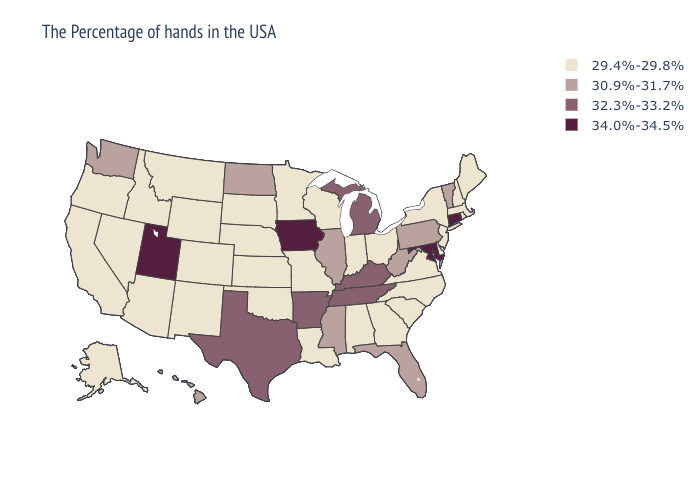Name the states that have a value in the range 32.3%-33.2%?
Concise answer only. Michigan, Kentucky, Tennessee, Arkansas, Texas. What is the lowest value in the MidWest?
Short answer required. 29.4%-29.8%. Does Missouri have a lower value than Alabama?
Concise answer only. No. What is the lowest value in the USA?
Write a very short answer. 29.4%-29.8%. Which states have the lowest value in the USA?
Keep it brief. Maine, Massachusetts, Rhode Island, New Hampshire, New York, New Jersey, Delaware, Virginia, North Carolina, South Carolina, Ohio, Georgia, Indiana, Alabama, Wisconsin, Louisiana, Missouri, Minnesota, Kansas, Nebraska, Oklahoma, South Dakota, Wyoming, Colorado, New Mexico, Montana, Arizona, Idaho, Nevada, California, Oregon, Alaska. What is the value of Pennsylvania?
Be succinct. 30.9%-31.7%. Does Ohio have the highest value in the MidWest?
Quick response, please. No. What is the value of New York?
Be succinct. 29.4%-29.8%. What is the highest value in states that border Washington?
Answer briefly. 29.4%-29.8%. What is the lowest value in the USA?
Quick response, please. 29.4%-29.8%. What is the lowest value in the USA?
Short answer required. 29.4%-29.8%. Among the states that border New Mexico , which have the highest value?
Answer briefly. Utah. Does the map have missing data?
Write a very short answer. No. Name the states that have a value in the range 29.4%-29.8%?
Quick response, please. Maine, Massachusetts, Rhode Island, New Hampshire, New York, New Jersey, Delaware, Virginia, North Carolina, South Carolina, Ohio, Georgia, Indiana, Alabama, Wisconsin, Louisiana, Missouri, Minnesota, Kansas, Nebraska, Oklahoma, South Dakota, Wyoming, Colorado, New Mexico, Montana, Arizona, Idaho, Nevada, California, Oregon, Alaska. What is the highest value in states that border Mississippi?
Be succinct. 32.3%-33.2%. 